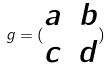<formula> <loc_0><loc_0><loc_500><loc_500>g = ( \begin{matrix} a & b \\ c & d \end{matrix} )</formula> 